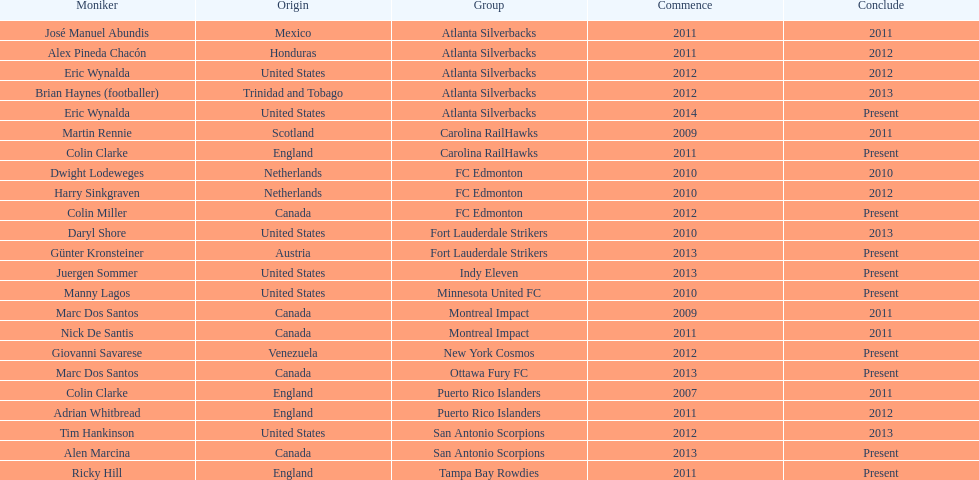Who is the last to coach the san antonio scorpions? Alen Marcina. 